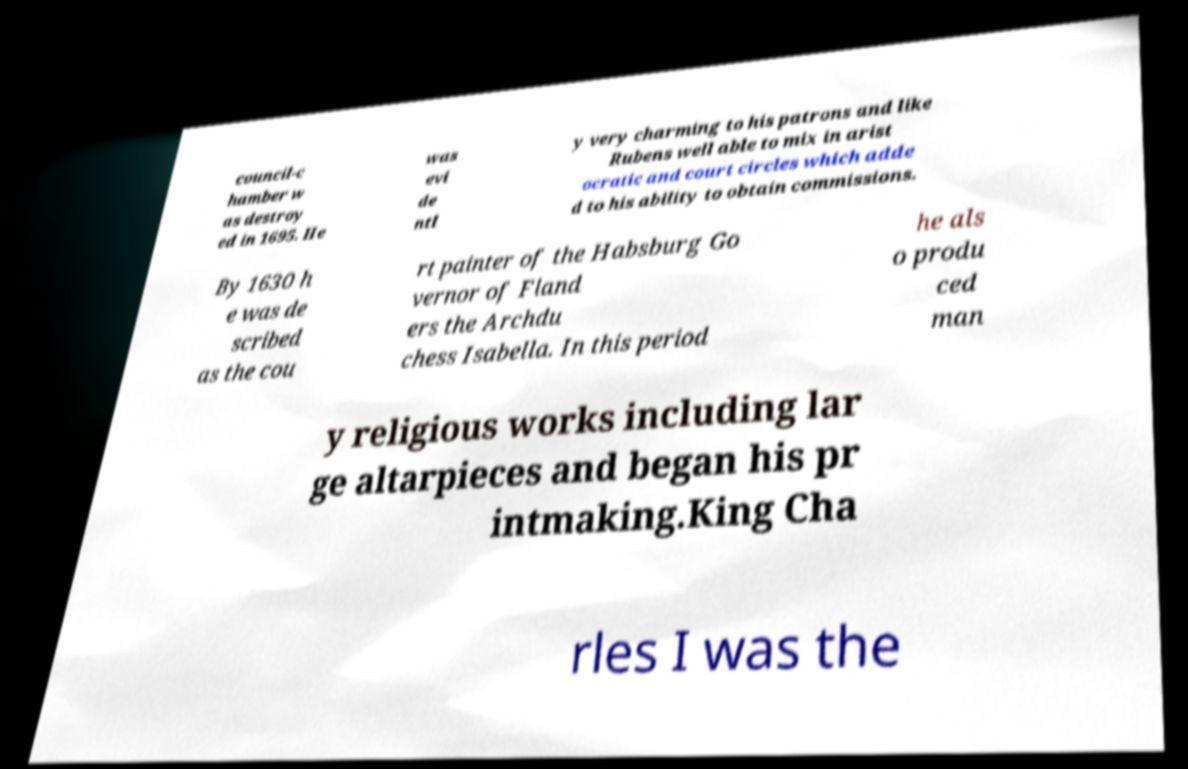What messages or text are displayed in this image? I need them in a readable, typed format. council-c hamber w as destroy ed in 1695. He was evi de ntl y very charming to his patrons and like Rubens well able to mix in arist ocratic and court circles which adde d to his ability to obtain commissions. By 1630 h e was de scribed as the cou rt painter of the Habsburg Go vernor of Fland ers the Archdu chess Isabella. In this period he als o produ ced man y religious works including lar ge altarpieces and began his pr intmaking.King Cha rles I was the 